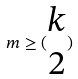<formula> <loc_0><loc_0><loc_500><loc_500>m \geq ( \begin{matrix} k \\ 2 \end{matrix} )</formula> 